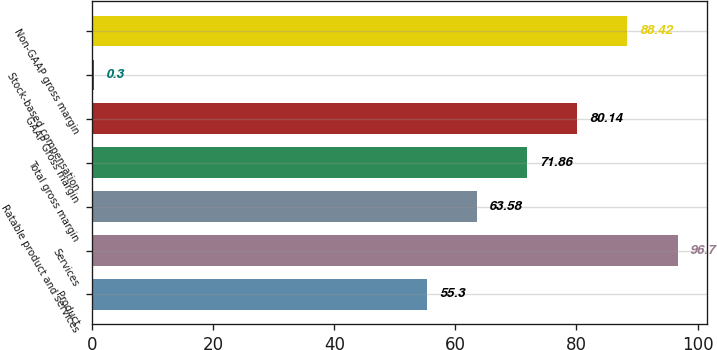<chart> <loc_0><loc_0><loc_500><loc_500><bar_chart><fcel>Product<fcel>Services<fcel>Ratable product and services<fcel>Total gross margin<fcel>GAAP Gross margin<fcel>Stock-based compensation<fcel>Non-GAAP gross margin<nl><fcel>55.3<fcel>96.7<fcel>63.58<fcel>71.86<fcel>80.14<fcel>0.3<fcel>88.42<nl></chart> 